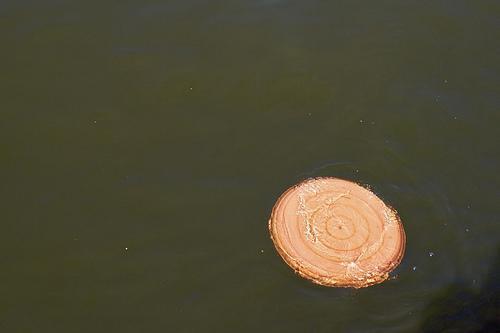How many images are there?
Give a very brief answer. 1. How many people have yellow surfboards?
Give a very brief answer. 0. 